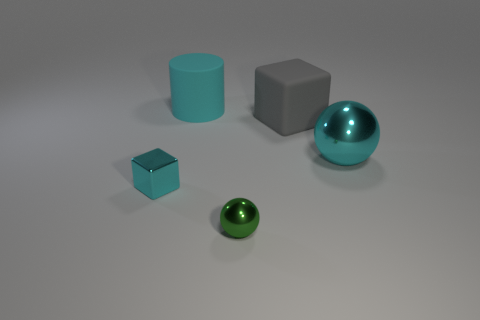Is the number of purple cylinders greater than the number of big spheres?
Offer a very short reply. No. Does the cyan cube have the same size as the block behind the large cyan sphere?
Offer a very short reply. No. There is a cube to the left of the large cube; what is its color?
Your answer should be compact. Cyan. What number of green objects are either big matte balls or small things?
Your answer should be very brief. 1. What is the color of the small ball?
Provide a succinct answer. Green. Is there any other thing that is made of the same material as the cyan sphere?
Ensure brevity in your answer.  Yes. Is the number of big rubber cubes that are behind the large matte cube less than the number of things to the right of the green metallic thing?
Keep it short and to the point. Yes. The cyan object that is on the left side of the big cyan shiny thing and in front of the large rubber block has what shape?
Make the answer very short. Cube. How many green metallic objects are the same shape as the small cyan shiny object?
Offer a terse response. 0. There is a cyan sphere that is the same material as the tiny green sphere; what size is it?
Keep it short and to the point. Large. 